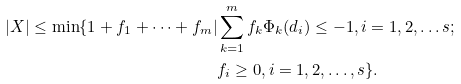<formula> <loc_0><loc_0><loc_500><loc_500>| X | \leq \min \{ 1 + f _ { 1 } + \cdots + f _ { m } | & \sum _ { k = 1 } ^ { m } f _ { k } \Phi _ { k } ( d _ { i } ) \leq - 1 , i = 1 , 2 , \dots s ; \\ & f _ { i } \geq 0 , i = 1 , 2 , \dots , s \} .</formula> 